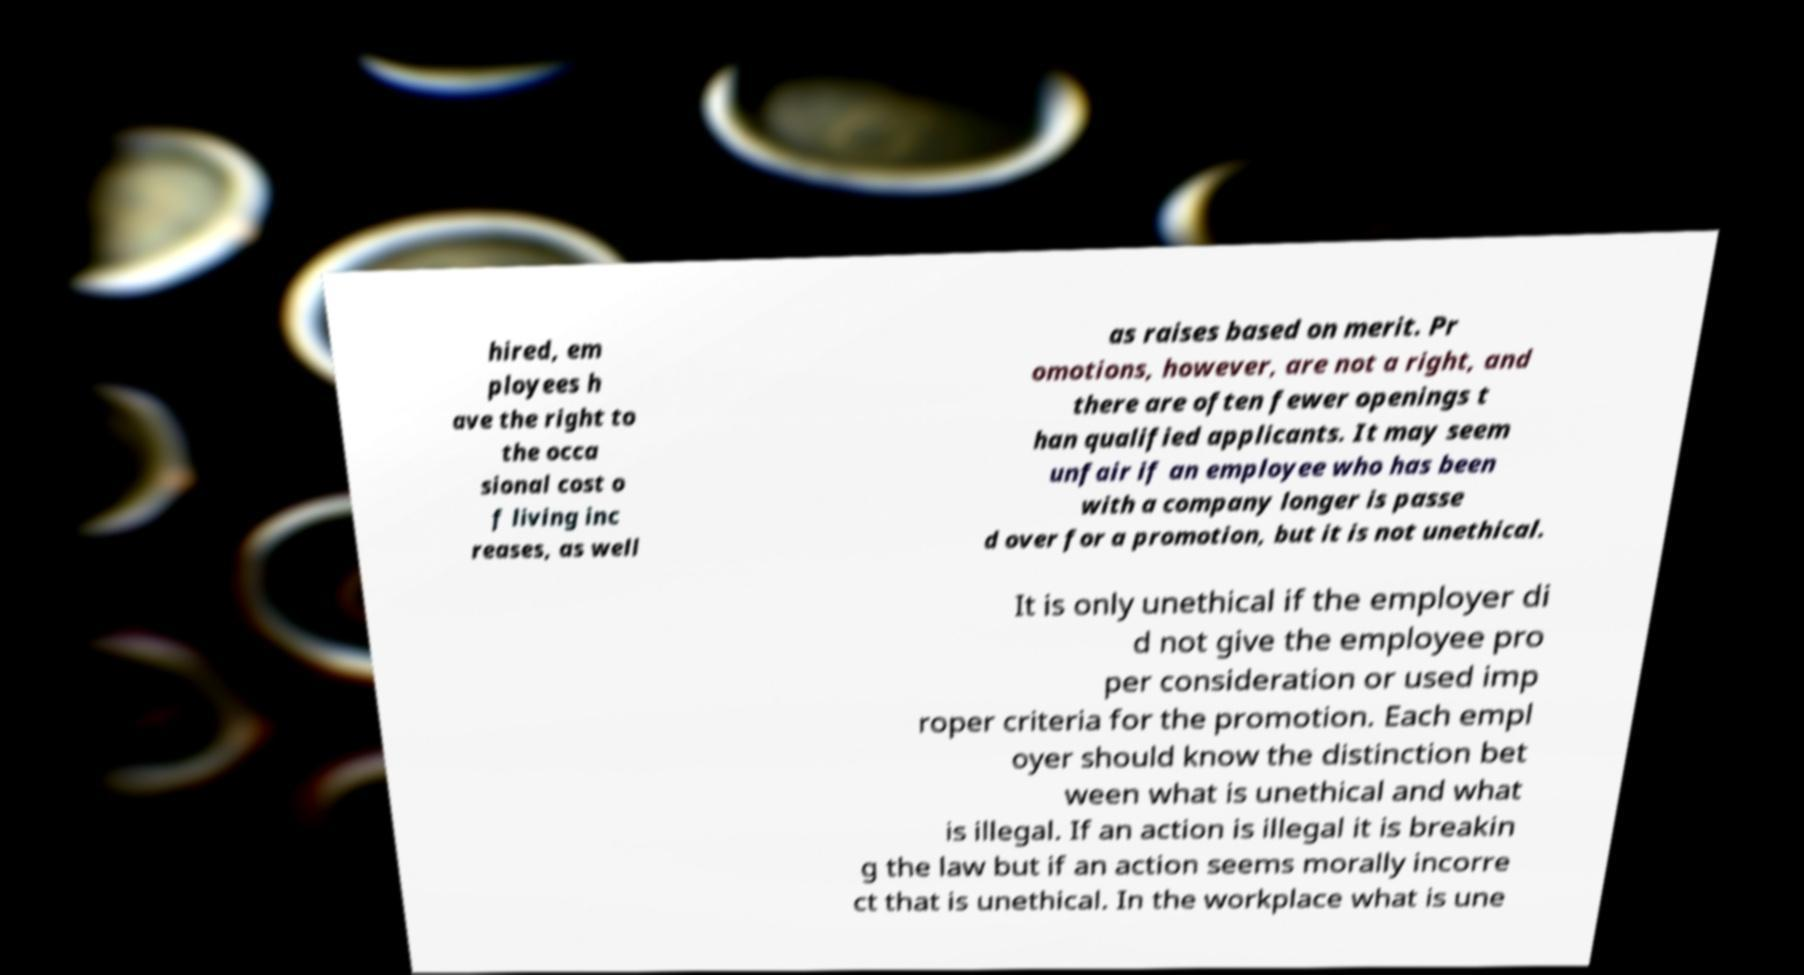Could you assist in decoding the text presented in this image and type it out clearly? hired, em ployees h ave the right to the occa sional cost o f living inc reases, as well as raises based on merit. Pr omotions, however, are not a right, and there are often fewer openings t han qualified applicants. It may seem unfair if an employee who has been with a company longer is passe d over for a promotion, but it is not unethical. It is only unethical if the employer di d not give the employee pro per consideration or used imp roper criteria for the promotion. Each empl oyer should know the distinction bet ween what is unethical and what is illegal. If an action is illegal it is breakin g the law but if an action seems morally incorre ct that is unethical. In the workplace what is une 